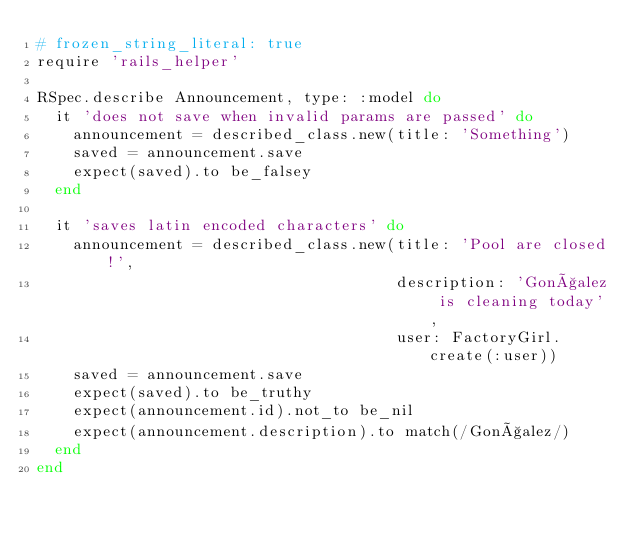Convert code to text. <code><loc_0><loc_0><loc_500><loc_500><_Ruby_># frozen_string_literal: true
require 'rails_helper'

RSpec.describe Announcement, type: :model do
  it 'does not save when invalid params are passed' do
    announcement = described_class.new(title: 'Something')
    saved = announcement.save
    expect(saved).to be_falsey
  end

  it 'saves latin encoded characters' do
    announcement = described_class.new(title: 'Pool are closed!',
                                       description: 'Gonçalez is cleaning today',
                                       user: FactoryGirl.create(:user))
    saved = announcement.save
    expect(saved).to be_truthy
    expect(announcement.id).not_to be_nil
    expect(announcement.description).to match(/Gonçalez/)
  end
end
</code> 